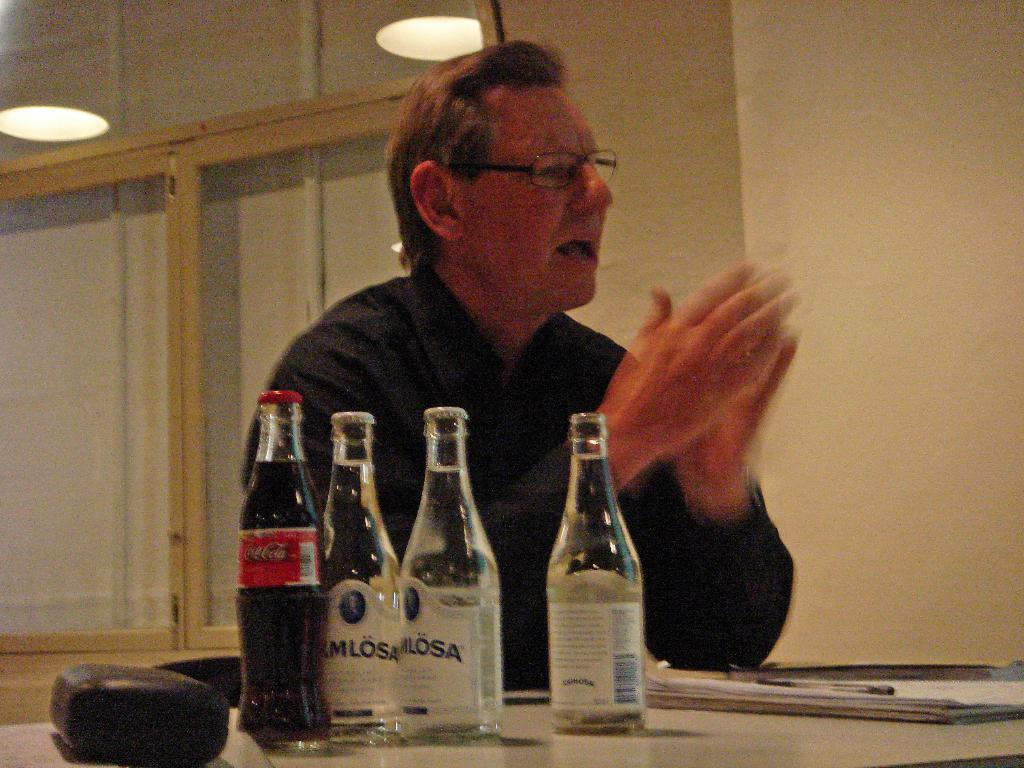<image>
Provide a brief description of the given image. A water bottle with the letters MLOSA on the label sits near some other bottles. 